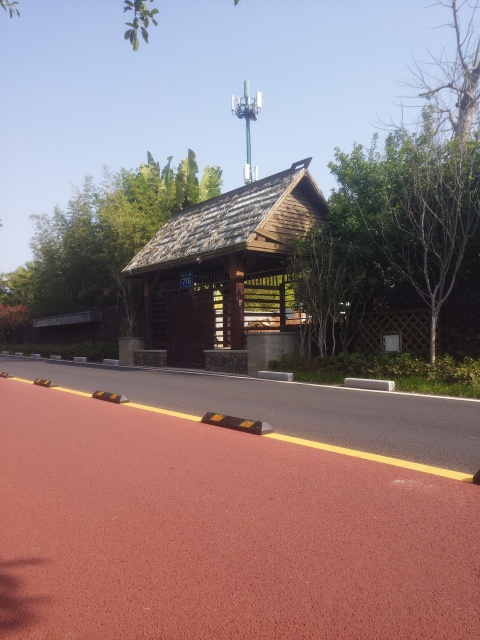Are the colors dull? The colors in the image are relatively vibrant, with a contrast of the warm red-brown tones of the running track against the greenery, accompanied by the rustic hues of the small house's wood and roof. There's also a clear blue sky that adds to the richness of the palette. 